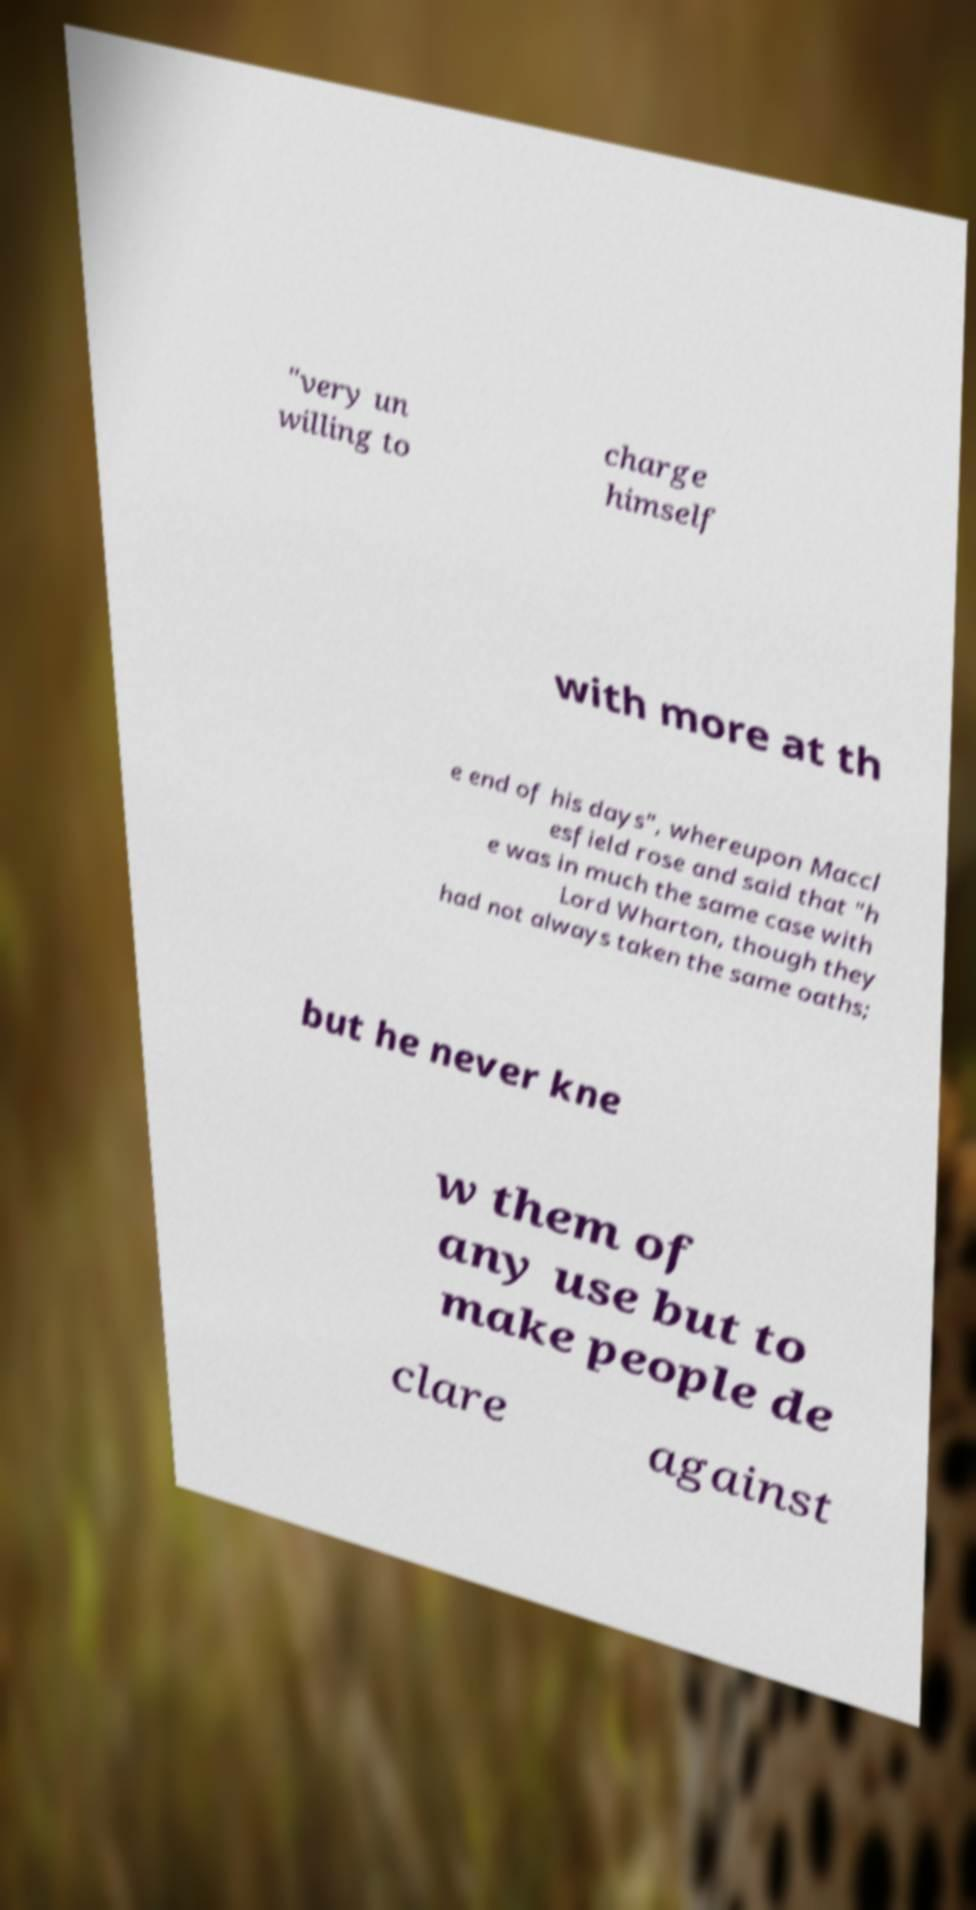For documentation purposes, I need the text within this image transcribed. Could you provide that? "very un willing to charge himself with more at th e end of his days", whereupon Maccl esfield rose and said that "h e was in much the same case with Lord Wharton, though they had not always taken the same oaths; but he never kne w them of any use but to make people de clare against 